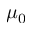<formula> <loc_0><loc_0><loc_500><loc_500>\mu _ { 0 }</formula> 